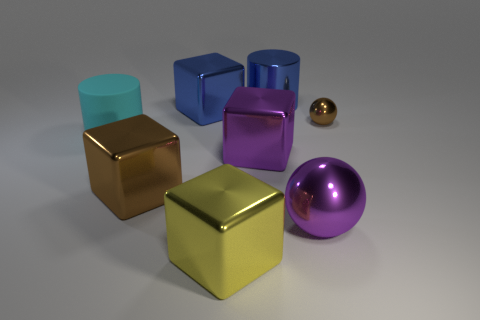Is the color of the block that is to the right of the big yellow cube the same as the big metal ball?
Provide a succinct answer. Yes. What is the color of the matte cylinder that is the same size as the blue shiny cube?
Ensure brevity in your answer.  Cyan. Are there the same number of purple cubes on the right side of the large purple sphere and cyan rubber cubes?
Your answer should be compact. Yes. There is a shiny sphere to the right of the large purple object that is on the right side of the shiny cylinder; what color is it?
Your answer should be compact. Brown. There is a ball behind the cyan matte thing on the left side of the big blue cylinder; what is its size?
Make the answer very short. Small. How many other objects are there of the same size as the shiny cylinder?
Ensure brevity in your answer.  6. There is a cylinder right of the yellow metallic thing in front of the cylinder right of the big blue block; what color is it?
Give a very brief answer. Blue. How many other things are the same shape as the large yellow metallic thing?
Provide a short and direct response. 3. What shape is the brown thing that is in front of the big cyan cylinder?
Offer a terse response. Cube. There is a shiny sphere that is behind the big cyan matte cylinder; is there a brown sphere in front of it?
Keep it short and to the point. No. 